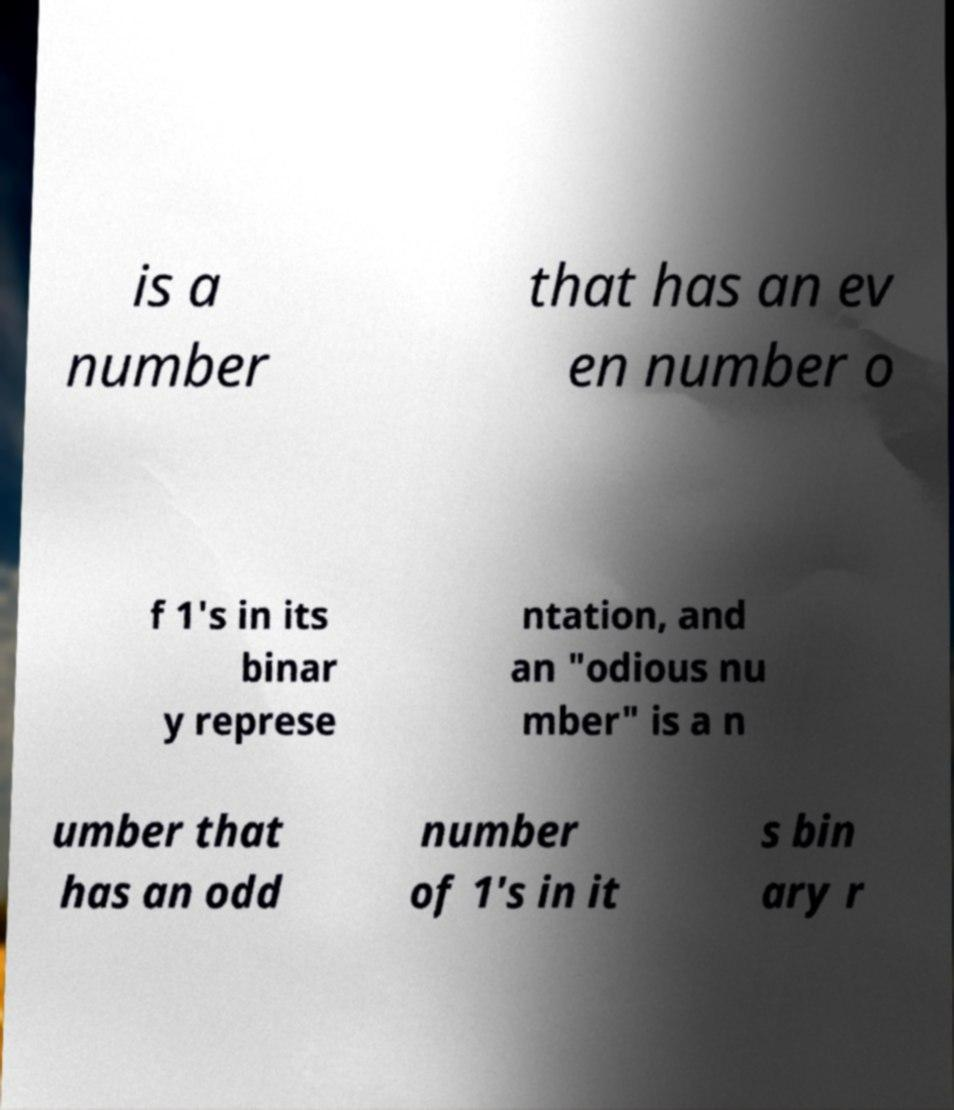Could you extract and type out the text from this image? is a number that has an ev en number o f 1's in its binar y represe ntation, and an "odious nu mber" is a n umber that has an odd number of 1's in it s bin ary r 